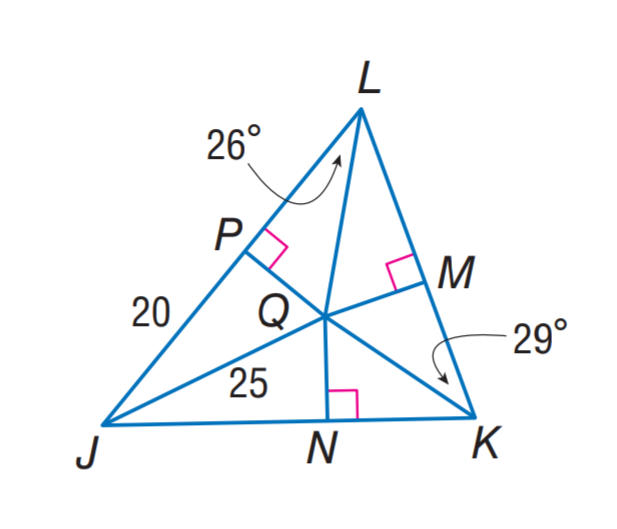Answer the mathemtical geometry problem and directly provide the correct option letter.
Question: Q is the incenter of \triangle J K L. Find m \angle Q J K.
Choices: A: 26 B: 29 C: 35 D: 70 C 